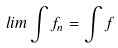<formula> <loc_0><loc_0><loc_500><loc_500>l i m \int f _ { n } = \int f</formula> 